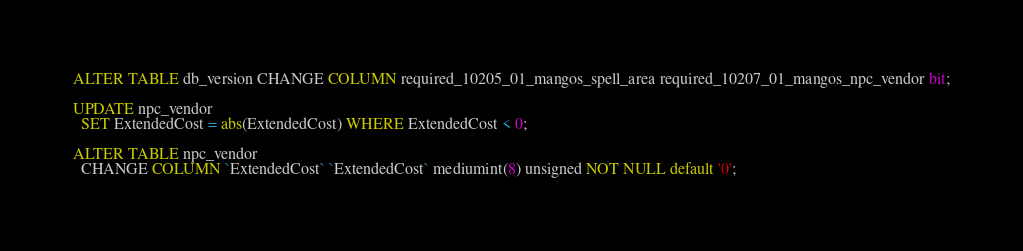<code> <loc_0><loc_0><loc_500><loc_500><_SQL_>ALTER TABLE db_version CHANGE COLUMN required_10205_01_mangos_spell_area required_10207_01_mangos_npc_vendor bit;

UPDATE npc_vendor
  SET ExtendedCost = abs(ExtendedCost) WHERE ExtendedCost < 0;

ALTER TABLE npc_vendor
  CHANGE COLUMN `ExtendedCost` `ExtendedCost` mediumint(8) unsigned NOT NULL default '0';
</code> 